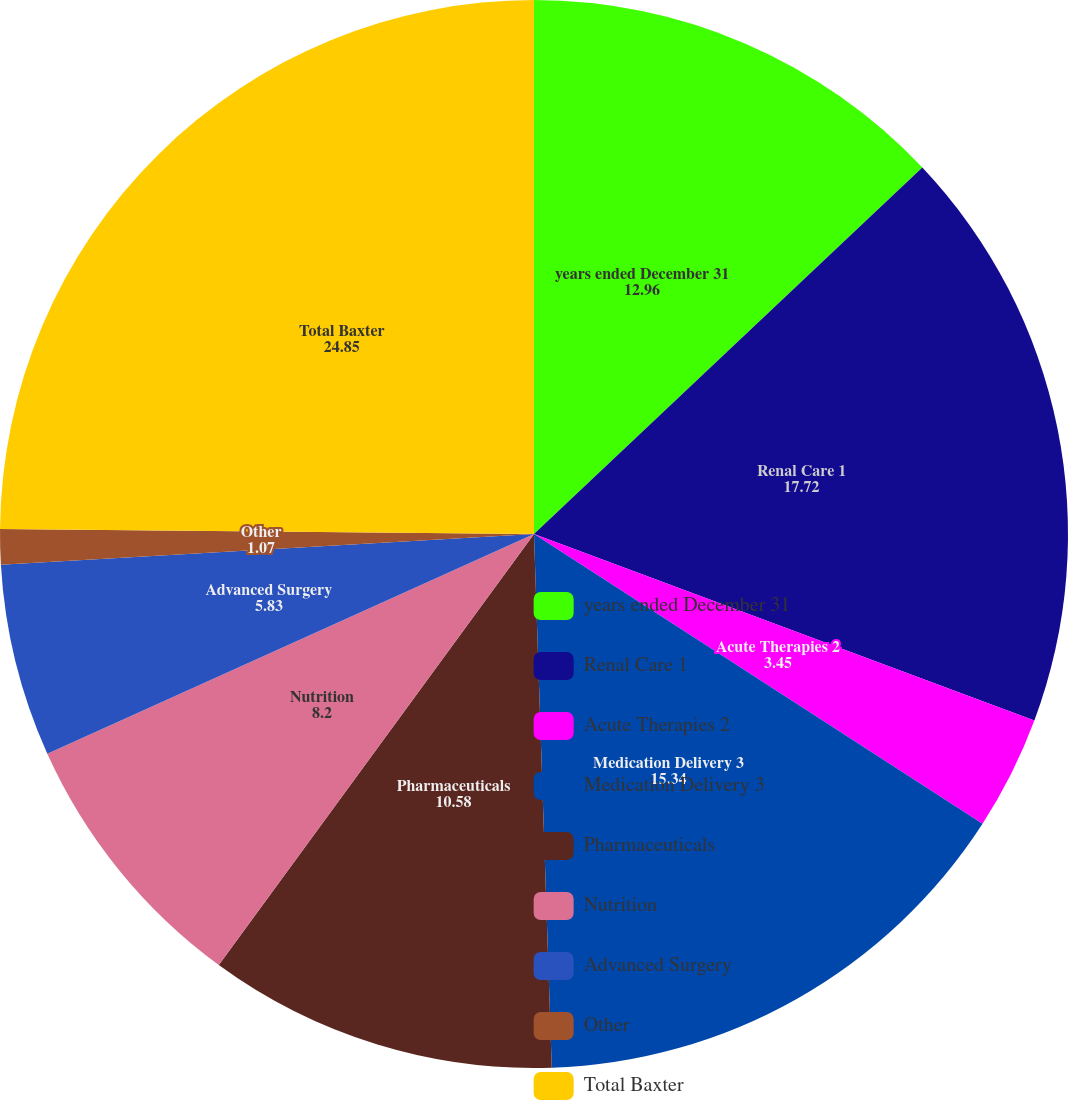Convert chart. <chart><loc_0><loc_0><loc_500><loc_500><pie_chart><fcel>years ended December 31<fcel>Renal Care 1<fcel>Acute Therapies 2<fcel>Medication Delivery 3<fcel>Pharmaceuticals<fcel>Nutrition<fcel>Advanced Surgery<fcel>Other<fcel>Total Baxter<nl><fcel>12.96%<fcel>17.72%<fcel>3.45%<fcel>15.34%<fcel>10.58%<fcel>8.2%<fcel>5.83%<fcel>1.07%<fcel>24.85%<nl></chart> 